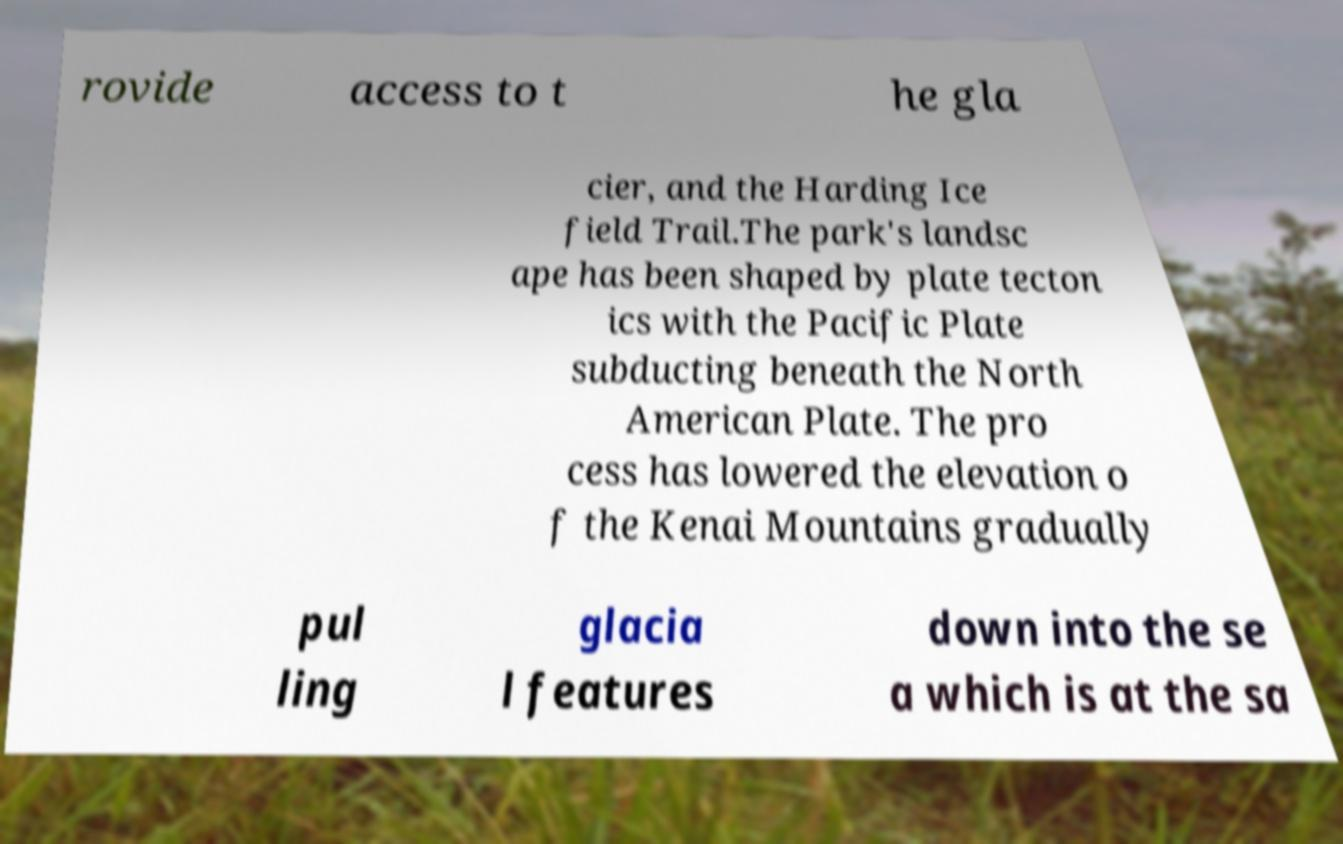Please read and relay the text visible in this image. What does it say? rovide access to t he gla cier, and the Harding Ice field Trail.The park's landsc ape has been shaped by plate tecton ics with the Pacific Plate subducting beneath the North American Plate. The pro cess has lowered the elevation o f the Kenai Mountains gradually pul ling glacia l features down into the se a which is at the sa 